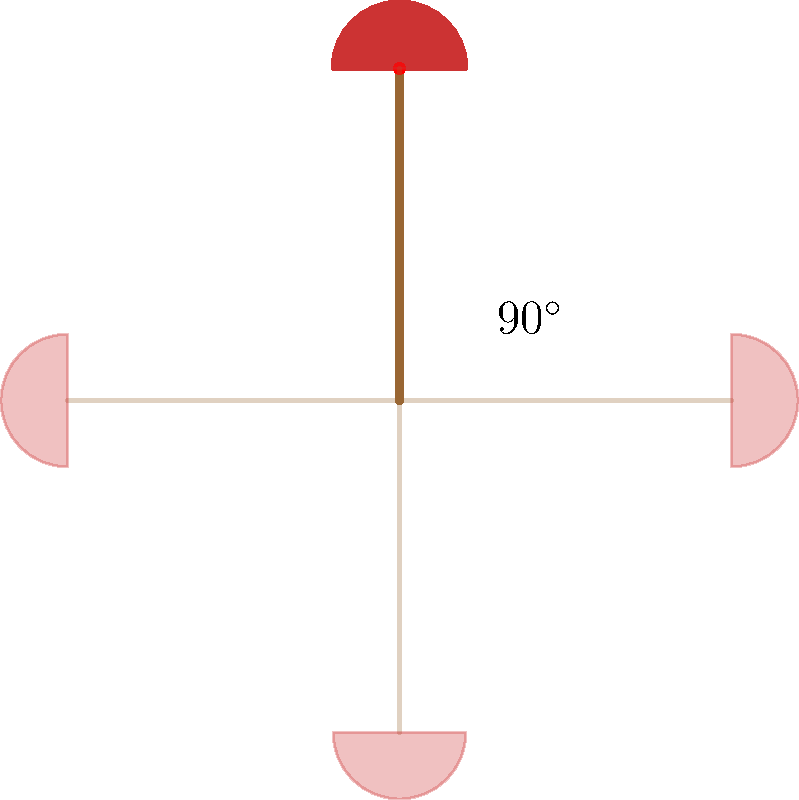A lacrosse stick, when viewed from above, has rotational symmetry. If the stick is rotated by 90° around its center point, it will look identical to its original position. How many unique positions can the lacrosse stick have when rotated around its center point before it returns to its original position? To solve this problem, we need to understand the concept of rotational symmetry and apply it to the lacrosse stick:

1. The lacrosse stick has a symmetrical shape when viewed from above.
2. The question states that a 90° rotation makes the stick look identical to its original position.
3. To find the number of unique positions, we need to determine how many 90° rotations are needed to complete a full 360° rotation.

Let's calculate:
1. One rotation: 90°
2. Two rotations: 90° + 90° = 180°
3. Three rotations: 180° + 90° = 270°
4. Four rotations: 270° + 90° = 360°

After four 90° rotations, we complete a full 360° circle and return to the original position.

Therefore, there are 4 unique positions (including the original position) that the lacrosse stick can have when rotated around its center point before returning to its original position.

This is also known as 4-fold rotational symmetry or C4 symmetry in group theory.
Answer: 4 